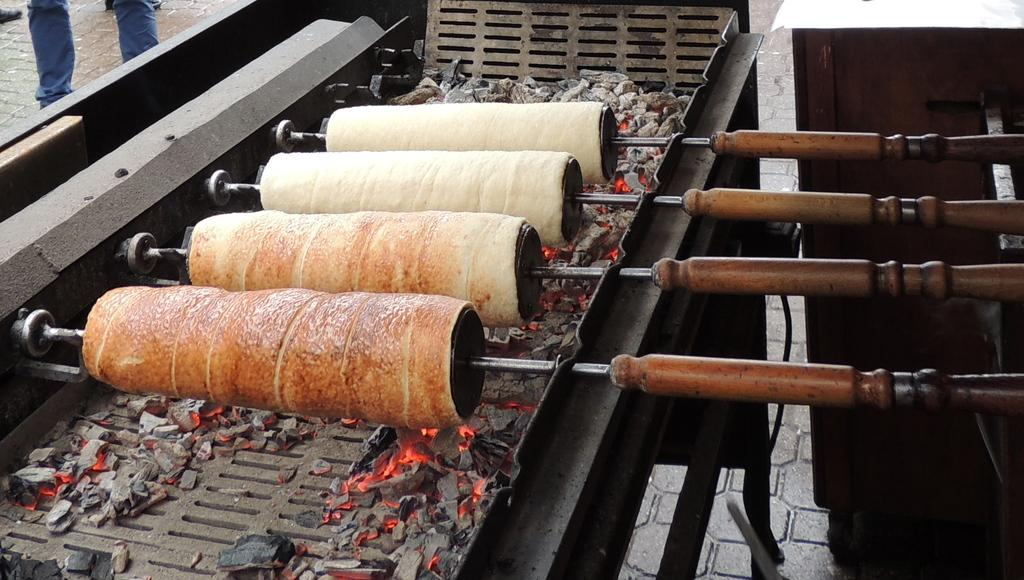What is present on the machine in the image? There are coals on a machine in the image. What is happening to the food items in the image? Food items are being rolled to the objects in the image. Who is giving a haircut to the apple in the image? There is no apple or haircut present in the image. How many seats are visible in the image? There is no mention of seats in the image. 